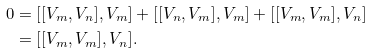<formula> <loc_0><loc_0><loc_500><loc_500>0 & = [ [ V _ { m } , V _ { n } ] , V _ { m } ] + [ [ V _ { n } , V _ { m } ] , V _ { m } ] + [ [ V _ { m } , V _ { m } ] , V _ { n } ] \\ & = [ [ V _ { m } , V _ { m } ] , V _ { n } ] .</formula> 